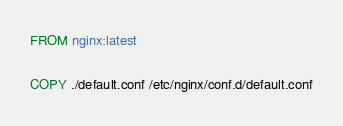Convert code to text. <code><loc_0><loc_0><loc_500><loc_500><_Dockerfile_>FROM nginx:latest

COPY ./default.conf /etc/nginx/conf.d/default.conf</code> 